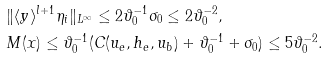Convert formula to latex. <formula><loc_0><loc_0><loc_500><loc_500>& \| \langle y \rangle ^ { l + 1 } \eta _ { i } \| _ { L ^ { \infty } } \leq 2 \vartheta _ { 0 } ^ { - 1 } \sigma _ { 0 } \leq 2 \vartheta _ { 0 } ^ { - 2 } , \\ & M ( x ) \leq \vartheta _ { 0 } ^ { - 1 } ( C ( u _ { e } , h _ { e } , u _ { b } ) + \vartheta _ { 0 } ^ { - 1 } + \sigma _ { 0 } ) \leq 5 \vartheta _ { 0 } ^ { - 2 } .</formula> 